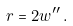<formula> <loc_0><loc_0><loc_500><loc_500>r = 2 w ^ { \prime \prime } \, .</formula> 